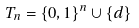Convert formula to latex. <formula><loc_0><loc_0><loc_500><loc_500>T _ { n } & = \{ 0 , 1 \} ^ { n } \cup \{ d \}</formula> 